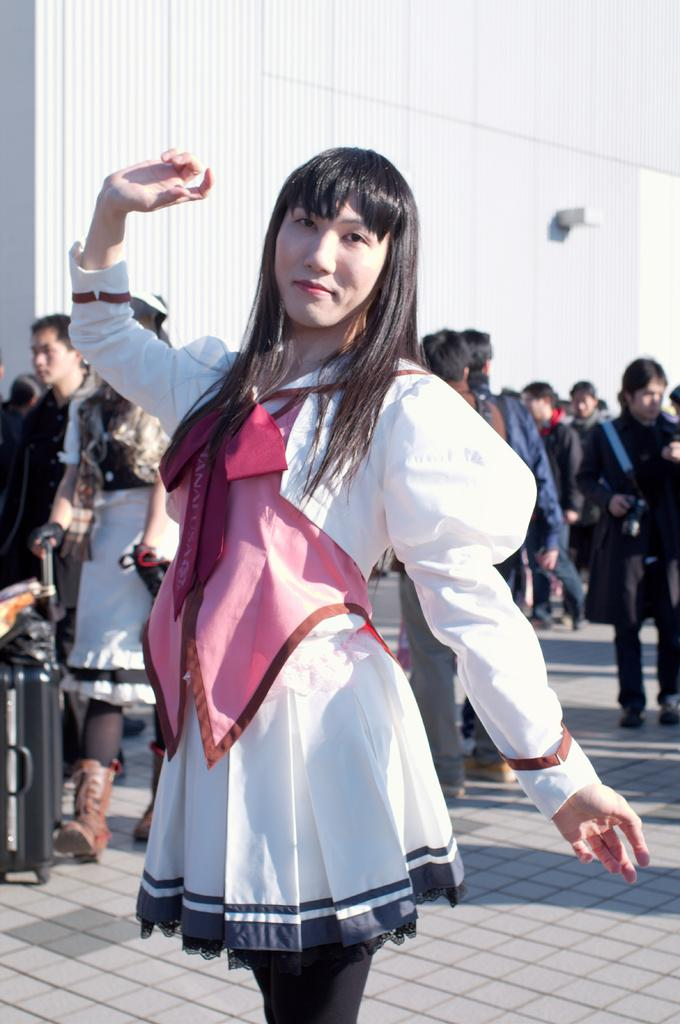What is the main subject of the image? There is a woman standing in the image. Can you describe the setting of the image? There is a group of people standing in the background of the image, and there is a building visible in the background as well. What type of harmony is being played by the clouds in the image? There are no clouds present in the image, and therefore no harmony can be played by them. 